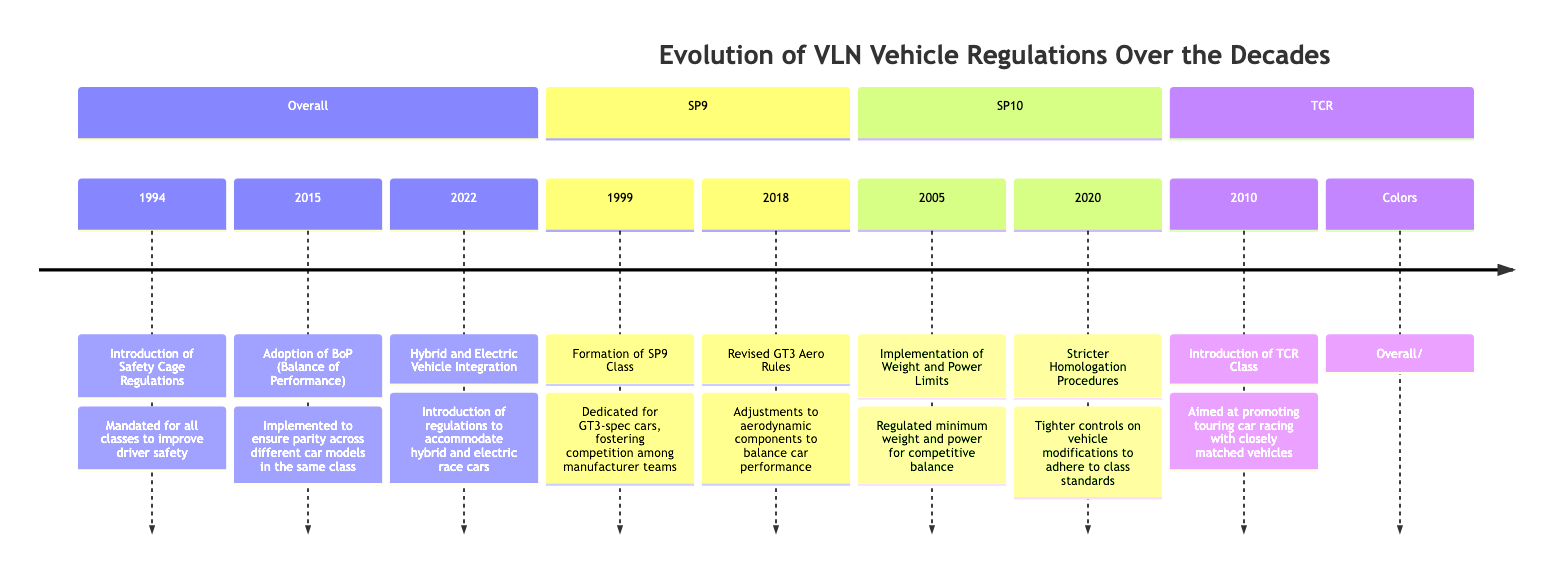What major regulation was introduced in 1994? The diagram indicates that in 1994, the "Introduction of Safety Cage Regulations" was a major regulation established to improve driver safety across all classes.
Answer: Introduction of Safety Cage Regulations How many classes are highlighted in the VLN evolution timeline? By examining the sections in the timeline, we can identify three distinct classes: SP9, SP10, and TCR, along with overall regulations. Thus, the total number of classes highlighted is three.
Answer: 3 What year was the TCR Class introduced? The TCR section of the diagram explicitly states that the TCR Class was introduced in 2010, clearly marking this year.
Answer: 2010 Which class had its formation in 1999? The diagram shows that the SP9 Class was formed in 1999, indicating a specific event related to that year.
Answer: SP9 Class What regulation change occurred in SP10 in 2020? The SP10 section indicates that in 2020, there was a "Stricter Homologation Procedures" implemented, which refers to changes in the regulations for vehicle modifications.
Answer: Stricter Homologation Procedures How many years elapsed between the introduction of the SP9 Class and the adoption of the BoP? By calculating from 1999 (SP9 Class) to 2015 (Adoption of BoP), the time that elapsed is 16 years.
Answer: 16 years What was the purpose of the "Adoption of BoP" in 2015? The diagram states that the Adoption of BoP was implemented to ensure parity across different car models in the same class, which highlights its purpose.
Answer: Ensure parity In which section do you find the implementation of weight and power limits? The implementation of weight and power limits is located in the SP10 section, pointing to the regulations that govern this particular class.
Answer: SP10 What color represents the Overall regulations in the diagram? Referring to the color coding mentioned in the diagram, Overall regulations are represented in orange (#ffa500).
Answer: #ffa500 